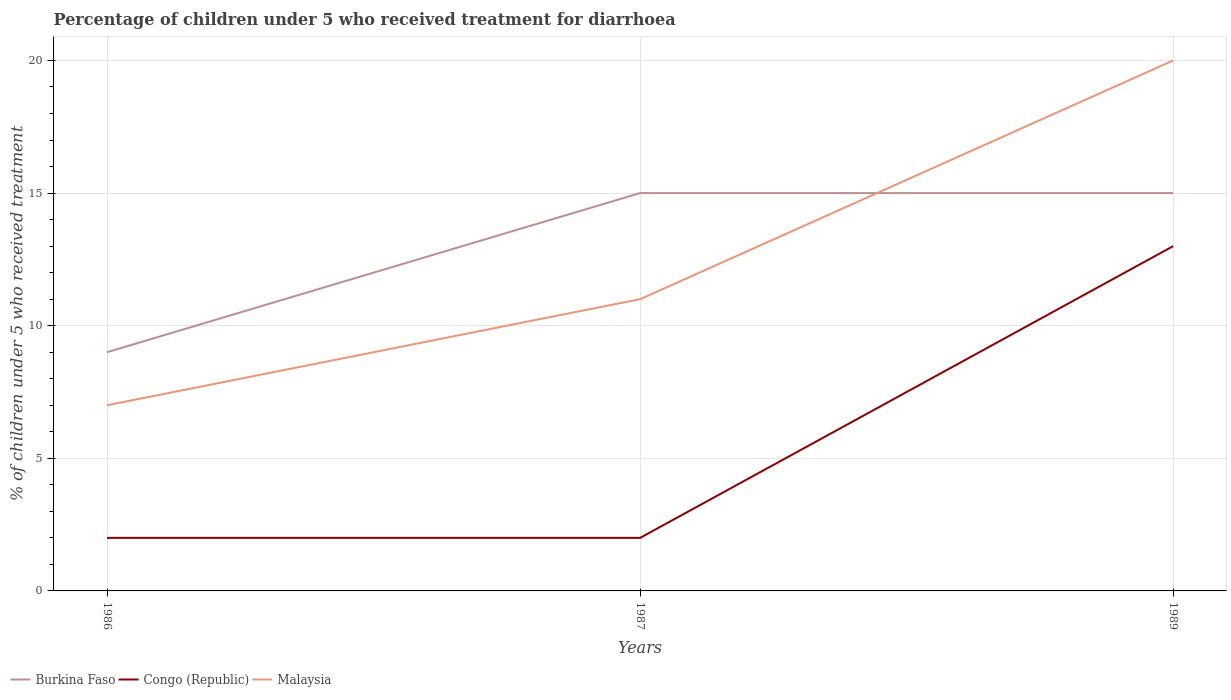How many different coloured lines are there?
Your answer should be very brief. 3. In which year was the percentage of children who received treatment for diarrhoea  in Malaysia maximum?
Give a very brief answer. 1986. What is the total percentage of children who received treatment for diarrhoea  in Congo (Republic) in the graph?
Your answer should be very brief. 0. What is the difference between the highest and the second highest percentage of children who received treatment for diarrhoea  in Malaysia?
Provide a succinct answer. 13. Is the percentage of children who received treatment for diarrhoea  in Congo (Republic) strictly greater than the percentage of children who received treatment for diarrhoea  in Burkina Faso over the years?
Provide a short and direct response. Yes. How many lines are there?
Your answer should be very brief. 3. How many years are there in the graph?
Make the answer very short. 3. Does the graph contain any zero values?
Give a very brief answer. No. What is the title of the graph?
Keep it short and to the point. Percentage of children under 5 who received treatment for diarrhoea. Does "West Bank and Gaza" appear as one of the legend labels in the graph?
Your answer should be very brief. No. What is the label or title of the X-axis?
Your response must be concise. Years. What is the label or title of the Y-axis?
Provide a short and direct response. % of children under 5 who received treatment. What is the % of children under 5 who received treatment of Burkina Faso in 1987?
Provide a short and direct response. 15. What is the % of children under 5 who received treatment of Malaysia in 1987?
Provide a succinct answer. 11. What is the % of children under 5 who received treatment in Congo (Republic) in 1989?
Your answer should be very brief. 13. Across all years, what is the minimum % of children under 5 who received treatment in Burkina Faso?
Ensure brevity in your answer.  9. Across all years, what is the minimum % of children under 5 who received treatment of Congo (Republic)?
Your answer should be very brief. 2. What is the total % of children under 5 who received treatment of Burkina Faso in the graph?
Your answer should be compact. 39. What is the total % of children under 5 who received treatment of Congo (Republic) in the graph?
Provide a succinct answer. 17. What is the difference between the % of children under 5 who received treatment in Malaysia in 1986 and that in 1987?
Your response must be concise. -4. What is the difference between the % of children under 5 who received treatment of Burkina Faso in 1986 and that in 1989?
Your response must be concise. -6. What is the difference between the % of children under 5 who received treatment of Congo (Republic) in 1986 and that in 1989?
Provide a short and direct response. -11. What is the difference between the % of children under 5 who received treatment in Congo (Republic) in 1987 and that in 1989?
Offer a terse response. -11. What is the difference between the % of children under 5 who received treatment in Burkina Faso in 1986 and the % of children under 5 who received treatment in Congo (Republic) in 1987?
Your answer should be compact. 7. What is the difference between the % of children under 5 who received treatment of Burkina Faso in 1986 and the % of children under 5 who received treatment of Malaysia in 1987?
Offer a very short reply. -2. What is the difference between the % of children under 5 who received treatment in Burkina Faso in 1986 and the % of children under 5 who received treatment in Congo (Republic) in 1989?
Your answer should be very brief. -4. What is the difference between the % of children under 5 who received treatment in Congo (Republic) in 1986 and the % of children under 5 who received treatment in Malaysia in 1989?
Provide a short and direct response. -18. What is the difference between the % of children under 5 who received treatment of Congo (Republic) in 1987 and the % of children under 5 who received treatment of Malaysia in 1989?
Give a very brief answer. -18. What is the average % of children under 5 who received treatment in Congo (Republic) per year?
Make the answer very short. 5.67. What is the average % of children under 5 who received treatment of Malaysia per year?
Provide a short and direct response. 12.67. In the year 1986, what is the difference between the % of children under 5 who received treatment of Burkina Faso and % of children under 5 who received treatment of Malaysia?
Keep it short and to the point. 2. In the year 1987, what is the difference between the % of children under 5 who received treatment of Burkina Faso and % of children under 5 who received treatment of Malaysia?
Ensure brevity in your answer.  4. In the year 1987, what is the difference between the % of children under 5 who received treatment of Congo (Republic) and % of children under 5 who received treatment of Malaysia?
Ensure brevity in your answer.  -9. In the year 1989, what is the difference between the % of children under 5 who received treatment in Burkina Faso and % of children under 5 who received treatment in Congo (Republic)?
Make the answer very short. 2. What is the ratio of the % of children under 5 who received treatment of Congo (Republic) in 1986 to that in 1987?
Your response must be concise. 1. What is the ratio of the % of children under 5 who received treatment of Malaysia in 1986 to that in 1987?
Your response must be concise. 0.64. What is the ratio of the % of children under 5 who received treatment of Congo (Republic) in 1986 to that in 1989?
Your response must be concise. 0.15. What is the ratio of the % of children under 5 who received treatment of Malaysia in 1986 to that in 1989?
Provide a succinct answer. 0.35. What is the ratio of the % of children under 5 who received treatment in Congo (Republic) in 1987 to that in 1989?
Offer a very short reply. 0.15. What is the ratio of the % of children under 5 who received treatment of Malaysia in 1987 to that in 1989?
Offer a terse response. 0.55. What is the difference between the highest and the second highest % of children under 5 who received treatment in Congo (Republic)?
Offer a very short reply. 11. What is the difference between the highest and the second highest % of children under 5 who received treatment of Malaysia?
Your response must be concise. 9. What is the difference between the highest and the lowest % of children under 5 who received treatment in Burkina Faso?
Keep it short and to the point. 6. What is the difference between the highest and the lowest % of children under 5 who received treatment of Congo (Republic)?
Your answer should be compact. 11. 